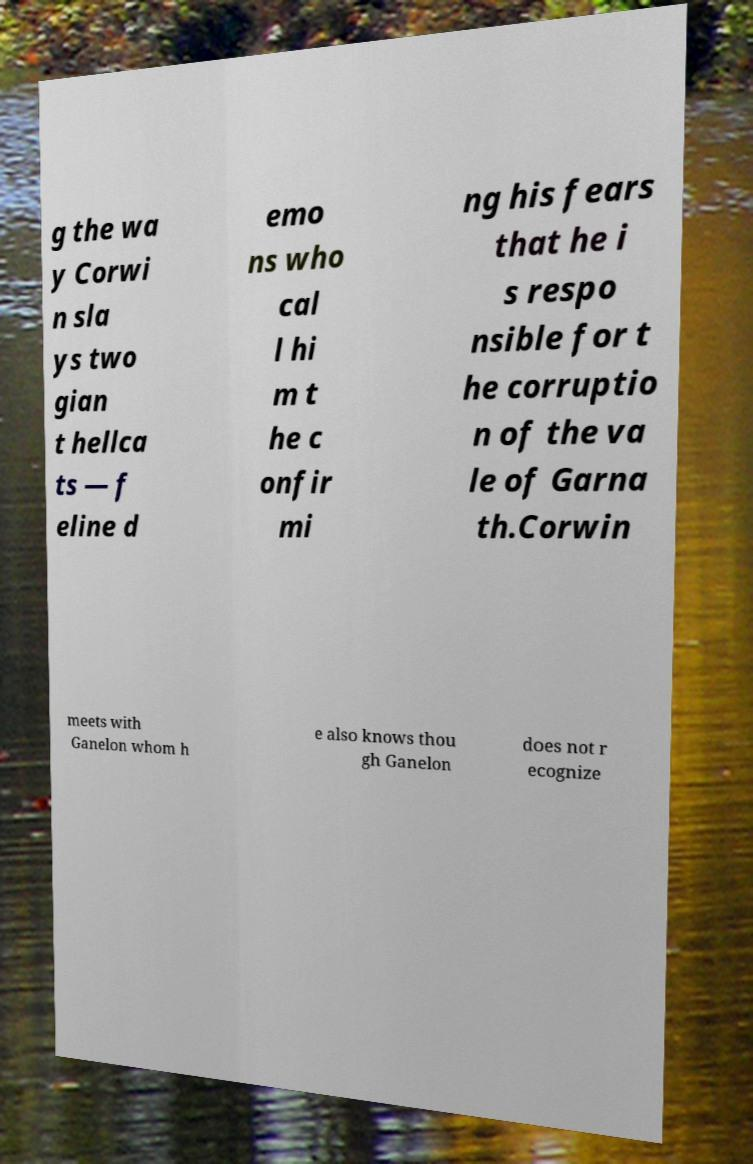Could you extract and type out the text from this image? g the wa y Corwi n sla ys two gian t hellca ts — f eline d emo ns who cal l hi m t he c onfir mi ng his fears that he i s respo nsible for t he corruptio n of the va le of Garna th.Corwin meets with Ganelon whom h e also knows thou gh Ganelon does not r ecognize 